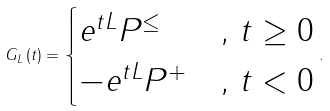<formula> <loc_0><loc_0><loc_500><loc_500>G _ { L } \left ( t \right ) = \begin{cases} e ^ { t L } P ^ { \leq } & , \, t \geq 0 \\ - e ^ { t L } P ^ { + } & , \, t < 0 \end{cases} .</formula> 